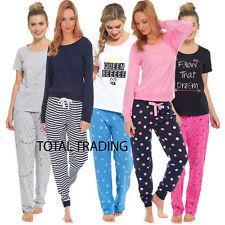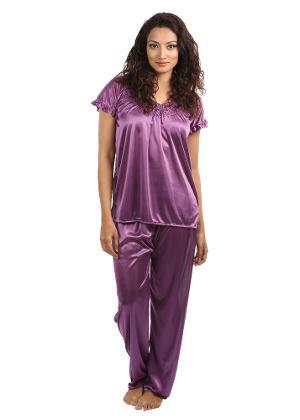The first image is the image on the left, the second image is the image on the right. Considering the images on both sides, is "There are at least four women in the image on the left." valid? Answer yes or no. Yes. 